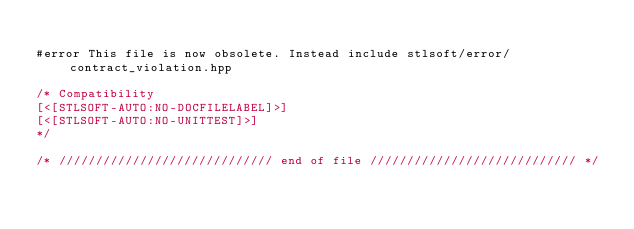Convert code to text. <code><loc_0><loc_0><loc_500><loc_500><_C++_>
#error This file is now obsolete. Instead include stlsoft/error/contract_violation.hpp

/* Compatibility
[<[STLSOFT-AUTO:NO-DOCFILELABEL]>]
[<[STLSOFT-AUTO:NO-UNITTEST]>]
*/

/* ///////////////////////////// end of file //////////////////////////// */</code> 